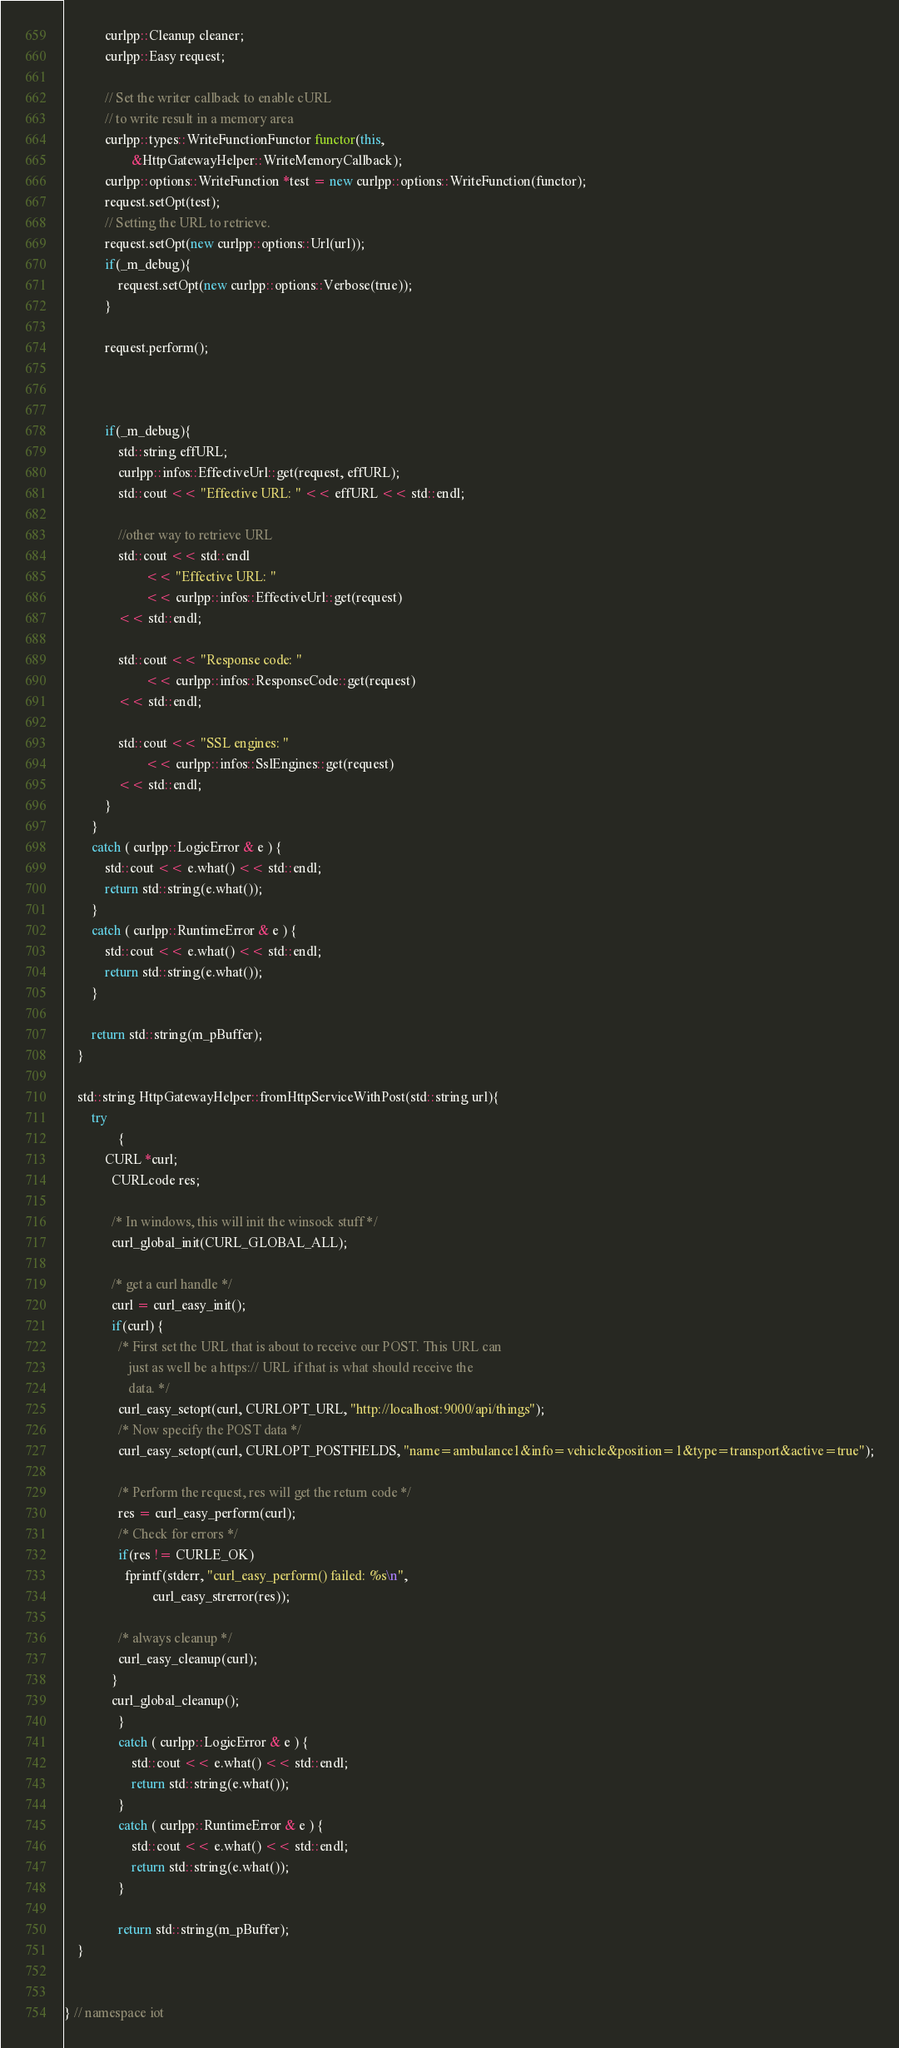Convert code to text. <code><loc_0><loc_0><loc_500><loc_500><_C++_>
			curlpp::Cleanup cleaner;
			curlpp::Easy request;

			// Set the writer callback to enable cURL
			// to write result in a memory area
			curlpp::types::WriteFunctionFunctor functor(this,
					&HttpGatewayHelper::WriteMemoryCallback);
			curlpp::options::WriteFunction *test = new curlpp::options::WriteFunction(functor);
			request.setOpt(test);
			// Setting the URL to retrieve.
			request.setOpt(new curlpp::options::Url(url));
			if(_m_debug){
				request.setOpt(new curlpp::options::Verbose(true));
			}

			request.perform();



			if(_m_debug){
				std::string effURL;
				curlpp::infos::EffectiveUrl::get(request, effURL);
				std::cout << "Effective URL: " << effURL << std::endl;

				//other way to retrieve URL
				std::cout << std::endl
						<< "Effective URL: "
						<< curlpp::infos::EffectiveUrl::get(request)
				<< std::endl;

				std::cout << "Response code: "
						<< curlpp::infos::ResponseCode::get(request)
				<< std::endl;

				std::cout << "SSL engines: "
						<< curlpp::infos::SslEngines::get(request)
				<< std::endl;
			}
		}
		catch ( curlpp::LogicError & e ) {
			std::cout << e.what() << std::endl;
			return std::string(e.what());
		}
		catch ( curlpp::RuntimeError & e ) {
			std::cout << e.what() << std::endl;
			return std::string(e.what());
		}

		return std::string(m_pBuffer);
	}

	std::string HttpGatewayHelper::fromHttpServiceWithPost(std::string url){
		try
				{
			CURL *curl;
			  CURLcode res;

			  /* In windows, this will init the winsock stuff */
			  curl_global_init(CURL_GLOBAL_ALL);

			  /* get a curl handle */
			  curl = curl_easy_init();
			  if(curl) {
			    /* First set the URL that is about to receive our POST. This URL can
			       just as well be a https:// URL if that is what should receive the
			       data. */
			    curl_easy_setopt(curl, CURLOPT_URL, "http://localhost:9000/api/things");
			    /* Now specify the POST data */
			    curl_easy_setopt(curl, CURLOPT_POSTFIELDS, "name=ambulance1&info=vehicle&position=1&type=transport&active=true");

			    /* Perform the request, res will get the return code */
			    res = curl_easy_perform(curl);
			    /* Check for errors */
			    if(res != CURLE_OK)
			      fprintf(stderr, "curl_easy_perform() failed: %s\n",
			              curl_easy_strerror(res));

			    /* always cleanup */
			    curl_easy_cleanup(curl);
			  }
			  curl_global_cleanup();
				}
				catch ( curlpp::LogicError & e ) {
					std::cout << e.what() << std::endl;
					return std::string(e.what());
				}
				catch ( curlpp::RuntimeError & e ) {
					std::cout << e.what() << std::endl;
					return std::string(e.what());
				}

				return std::string(m_pBuffer);
	}


} // namespace iot


</code> 